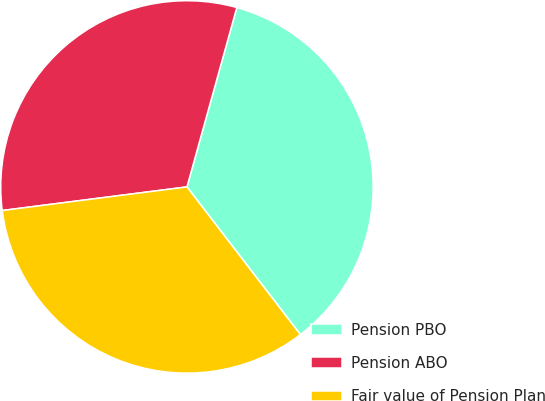<chart> <loc_0><loc_0><loc_500><loc_500><pie_chart><fcel>Pension PBO<fcel>Pension ABO<fcel>Fair value of Pension Plan<nl><fcel>35.26%<fcel>31.34%<fcel>33.4%<nl></chart> 